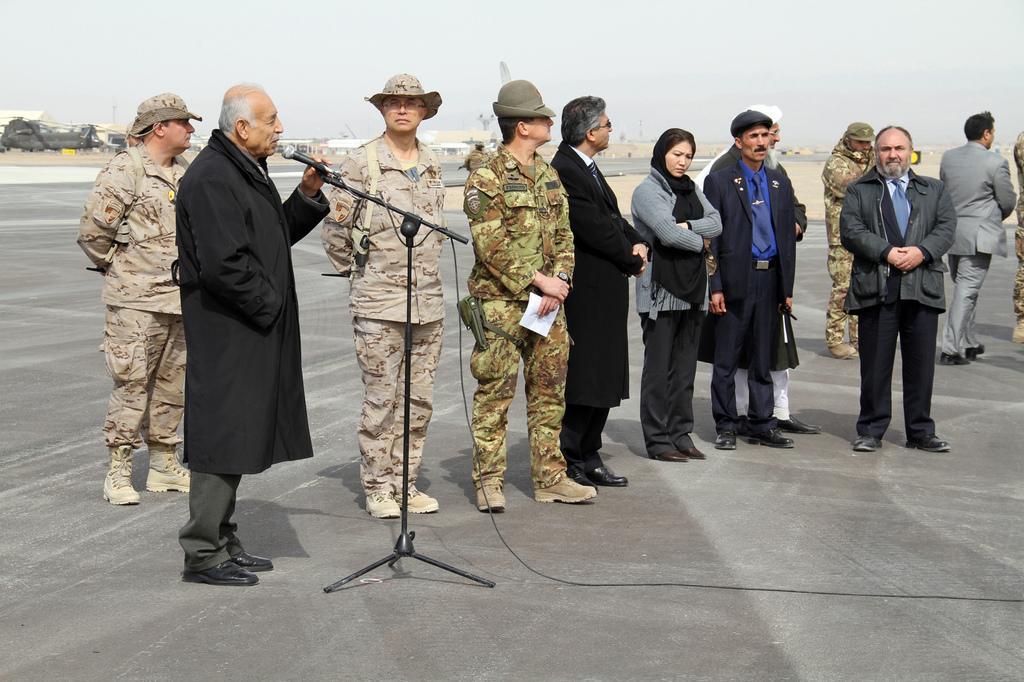In one or two sentences, can you explain what this image depicts? In this picture we can see a group of people on the ground, man holding a mic with his hand and in the background we can see houses, some objects and the sky. 